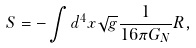Convert formula to latex. <formula><loc_0><loc_0><loc_500><loc_500>S = - \int d ^ { 4 } x \sqrt { g } \frac { 1 } { 1 6 \pi G _ { N } } R ,</formula> 